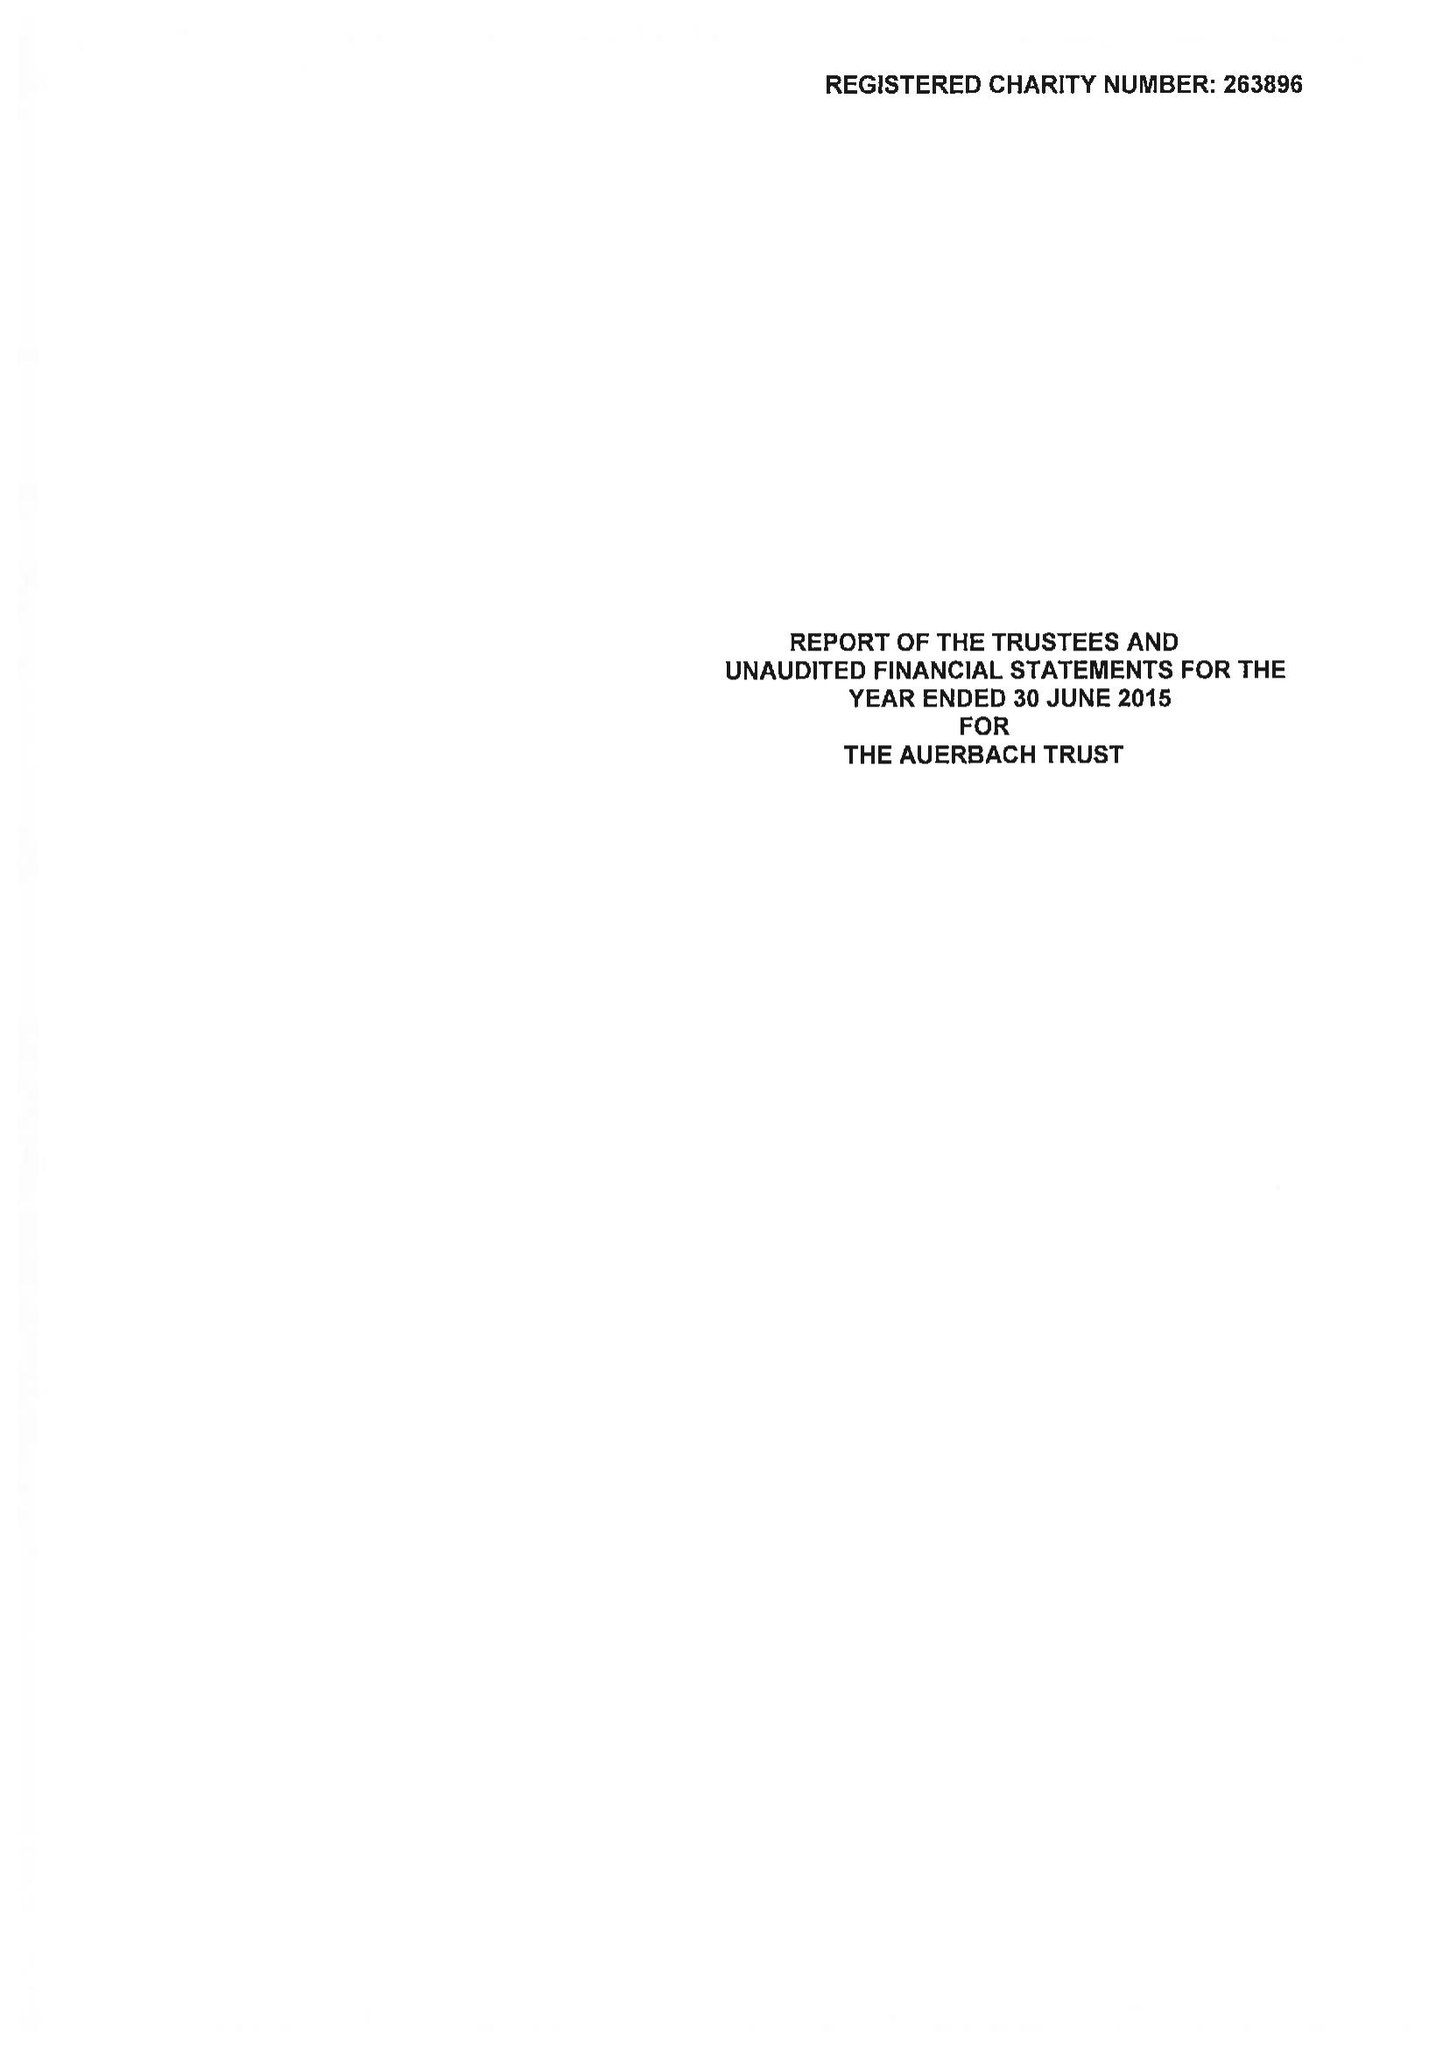What is the value for the address__street_line?
Answer the question using a single word or phrase. 21 CLARENCE TERRACE 